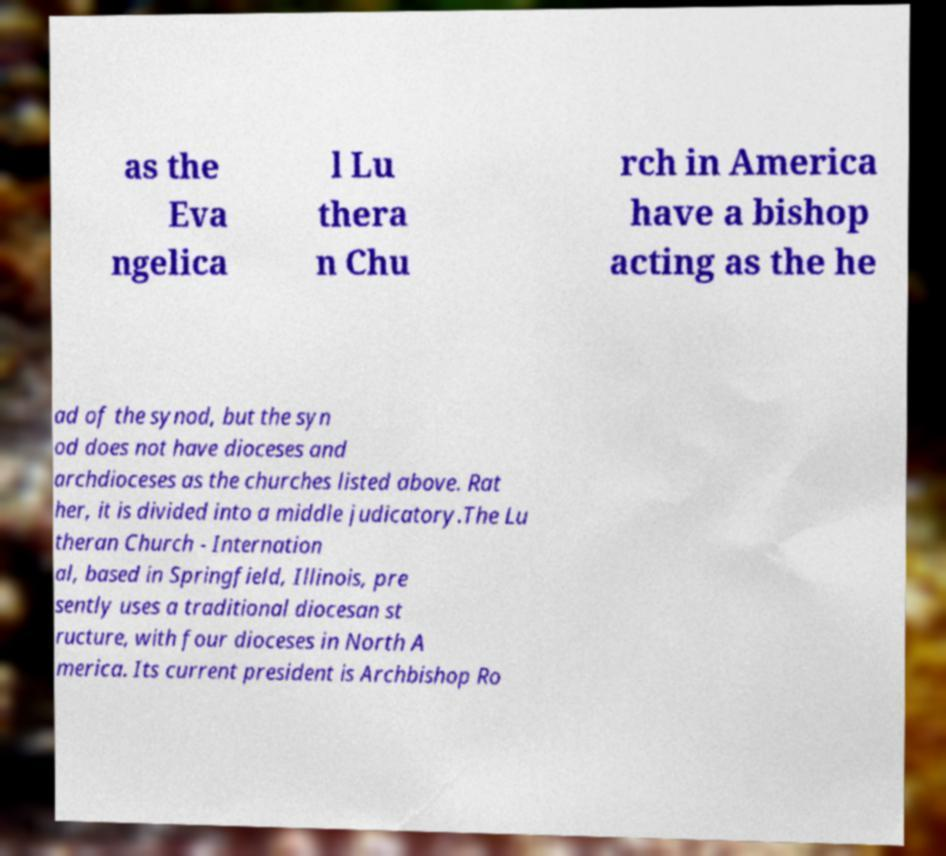Can you read and provide the text displayed in the image?This photo seems to have some interesting text. Can you extract and type it out for me? as the Eva ngelica l Lu thera n Chu rch in America have a bishop acting as the he ad of the synod, but the syn od does not have dioceses and archdioceses as the churches listed above. Rat her, it is divided into a middle judicatory.The Lu theran Church - Internation al, based in Springfield, Illinois, pre sently uses a traditional diocesan st ructure, with four dioceses in North A merica. Its current president is Archbishop Ro 